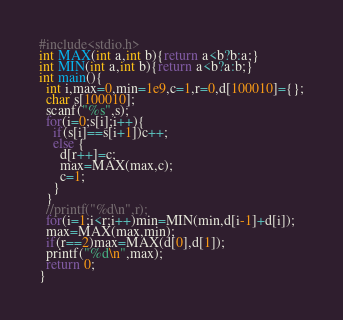Convert code to text. <code><loc_0><loc_0><loc_500><loc_500><_C_>#include<stdio.h>
int MAX(int a,int b){return a<b?b:a;}
int MIN(int a,int b){return a<b?a:b;}
int main(){
  int i,max=0,min=1e9,c=1,r=0,d[100010]={};
  char s[100010];
  scanf("%s",s);
  for(i=0;s[i];i++){
    if(s[i]==s[i+1])c++;
    else {
      d[r++]=c;
      max=MAX(max,c);
      c=1;
    }
  }
  //printf("%d\n",r);
  for(i=1;i<r;i++)min=MIN(min,d[i-1]+d[i]);
  max=MAX(max,min);
  if(r==2)max=MAX(d[0],d[1]);
  printf("%d\n",max);
  return 0;
}
</code> 